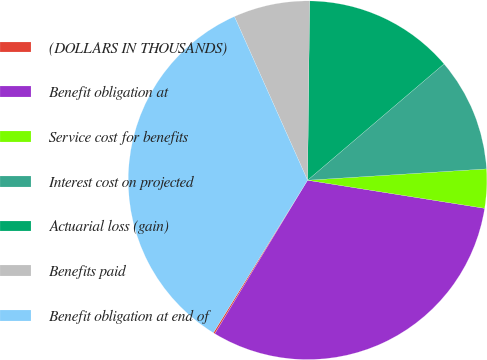<chart> <loc_0><loc_0><loc_500><loc_500><pie_chart><fcel>(DOLLARS IN THOUSANDS)<fcel>Benefit obligation at<fcel>Service cost for benefits<fcel>Interest cost on projected<fcel>Actuarial loss (gain)<fcel>Benefits paid<fcel>Benefit obligation at end of<nl><fcel>0.15%<fcel>31.15%<fcel>3.51%<fcel>10.23%<fcel>13.58%<fcel>6.87%<fcel>34.51%<nl></chart> 